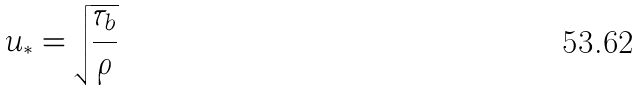<formula> <loc_0><loc_0><loc_500><loc_500>u _ { * } = \sqrt { \frac { \tau _ { b } } { \rho } }</formula> 